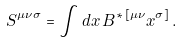<formula> <loc_0><loc_0><loc_500><loc_500>S ^ { \mu \nu \sigma } = \int d x \, B ^ { * \, [ \mu \nu } x ^ { \sigma ] } \, .</formula> 